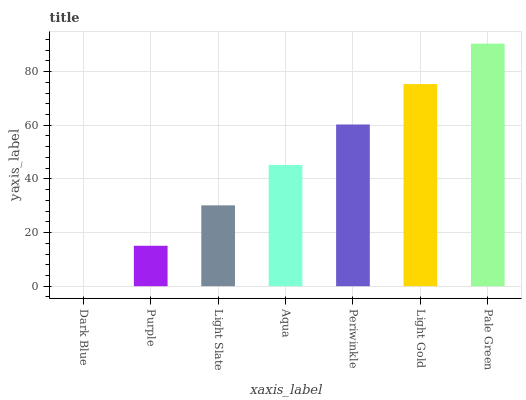Is Purple the minimum?
Answer yes or no. No. Is Purple the maximum?
Answer yes or no. No. Is Purple greater than Dark Blue?
Answer yes or no. Yes. Is Dark Blue less than Purple?
Answer yes or no. Yes. Is Dark Blue greater than Purple?
Answer yes or no. No. Is Purple less than Dark Blue?
Answer yes or no. No. Is Aqua the high median?
Answer yes or no. Yes. Is Aqua the low median?
Answer yes or no. Yes. Is Light Slate the high median?
Answer yes or no. No. Is Dark Blue the low median?
Answer yes or no. No. 